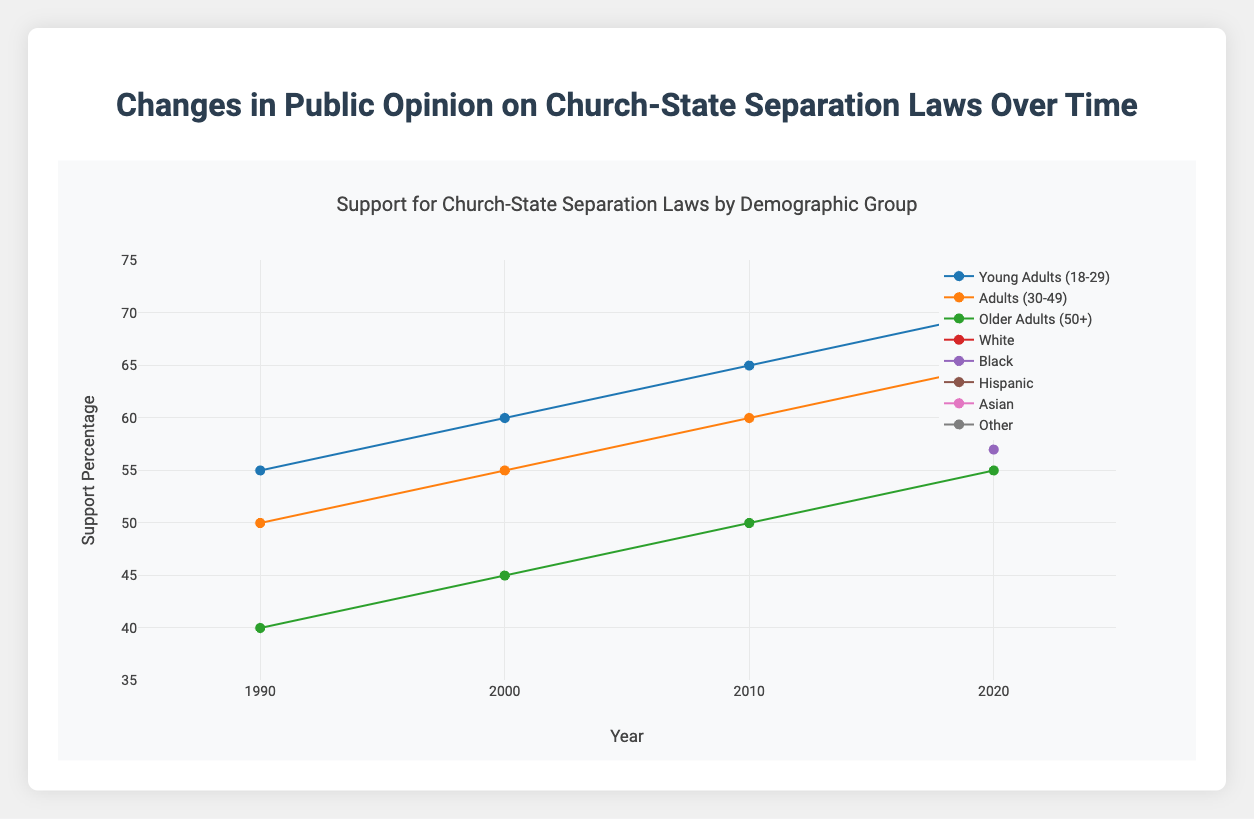What is the title of the chart? The title is usually written at the top of the chart, and in this case, it is 'Support for Church-State Separation Laws by Demographic Group'.
Answer: Support for Church-State Separation Laws by Demographic Group What is the range of the y-axis? The range of the y-axis can be found by looking at the lowest and highest values on the y-axis. Here, it ranges from 35 to 75.
Answer: 35 to 75 How many demographic groups are shown in the data? By examining the legend or the distinct lines/markers in the plot, one can count the number of demographic groups represented. There are 5 groups related to ages and 5 related to races, making it 10 in total.
Answer: 10 Which group had the highest support percentage in 2020? Home in on the data points for the year 2020 and look at the percentages. The Asian group has the highest support at 68%.
Answer: Asian Which age group had the lowest increase in support percentage from 1990 to 2020? To find this, calculate the change in support percentage for each age group from 1990 to 2020 and identify the smallest difference. Older Adults (50+) went from 40% to 55%, an increase of 15%.
Answer: Older Adults (50+) How does the support percentage of Young Adults (18-29) change over time? Trace the line or dots representing Young Adults (18-29) across the years. The support percentage increases progressively: 55% (1990), 60% (2000), 65% (2010), 70% (2020).
Answer: It increases consistently Considering all the age groups, what is the average support percentage in 2000? Extract the support percentages for each age group in 2000: Young Adults (60), Adults (55), Older Adults (45). Calculate the average: (60 + 55 + 45) / 3 = 53.33%.
Answer: 53.33% Which group had the consistent trend in support for church-state separation over the decades? Examine the lines/trend of each group for consistency. Young Adults (18-29) show a steady and consistent rise from 55% to 70% over the decades.
Answer: Young Adults (18-29) What was the difference in support percentage between Young Adults (18-29) and Older Adults (50+) in 1990? Find the support percentages for these two groups in 1990: Young Adults (55) and Older Adults (40). Calculate the difference: 55 - 40 = 15%.
Answer: 15% What can be inferred about racial demographic support for church-state separation in 2020? Look at the support percentages of all racial groups in 2020: White (63), Black (57), Hispanic (60), Asian (68), Other (61). The support varies but is generally above 50%, with Asians having the highest support.
Answer: Most racial demographics support church-state separation with Asian having the highest 